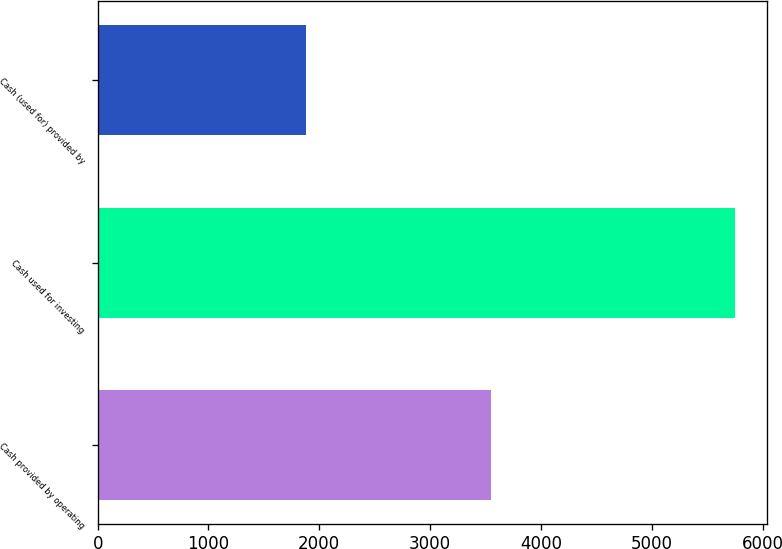<chart> <loc_0><loc_0><loc_500><loc_500><bar_chart><fcel>Cash provided by operating<fcel>Cash used for investing<fcel>Cash (used for) provided by<nl><fcel>3552<fcel>5753<fcel>1884<nl></chart> 